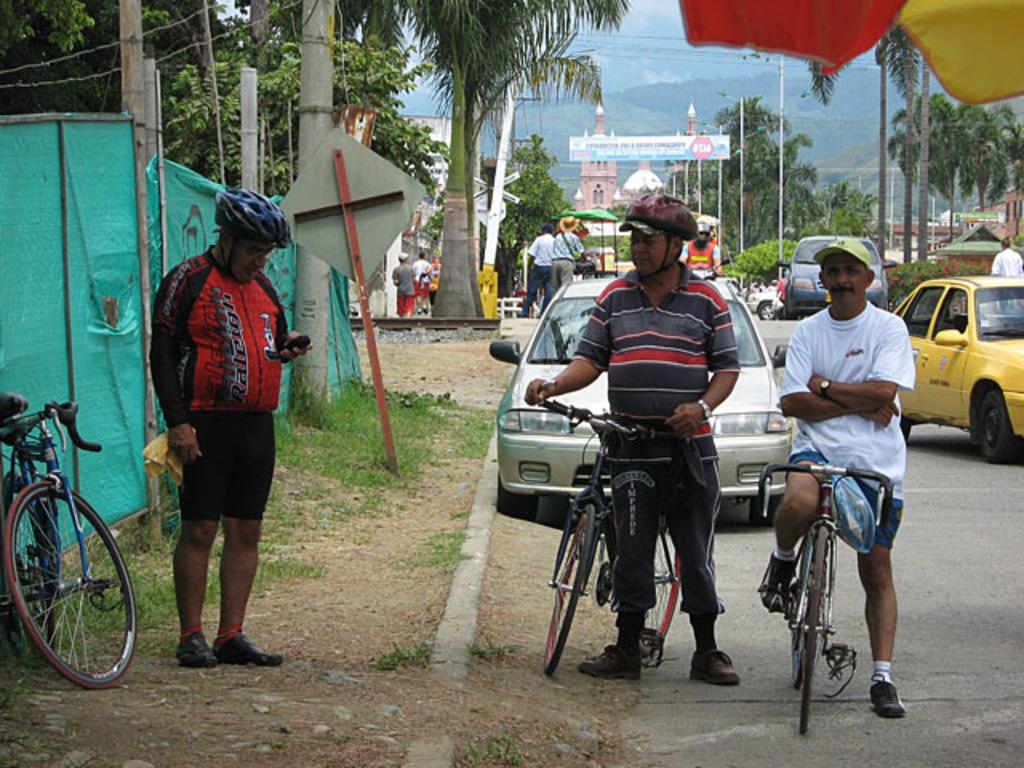How many people are in the image? There are three persons in the image. What are the persons doing in the image? The image does not show what the persons are doing, but it does show that they are with bicycles. What else can be seen on the road in the image? There are cars on the road in the image. What type of vegetation is present in the image? There are trees in the image. What structure can be seen in the image? There is a pole in the image. What type of business is being conducted in the quicksand in the image? There is no quicksand or business activity present in the image. 